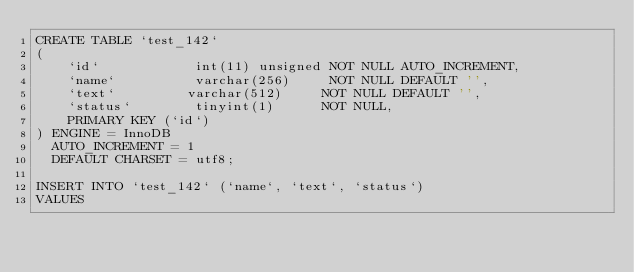<code> <loc_0><loc_0><loc_500><loc_500><_SQL_>CREATE TABLE `test_142`
(
    `id`            int(11) unsigned NOT NULL AUTO_INCREMENT,
    `name`          varchar(256)     NOT NULL DEFAULT '',
    `text`         varchar(512)     NOT NULL DEFAULT '',
    `status`        tinyint(1)      NOT NULL,
    PRIMARY KEY (`id`)
) ENGINE = InnoDB
  AUTO_INCREMENT = 1
  DEFAULT CHARSET = utf8;

INSERT INTO `test_142` (`name`, `text`, `status`)
VALUES</code> 